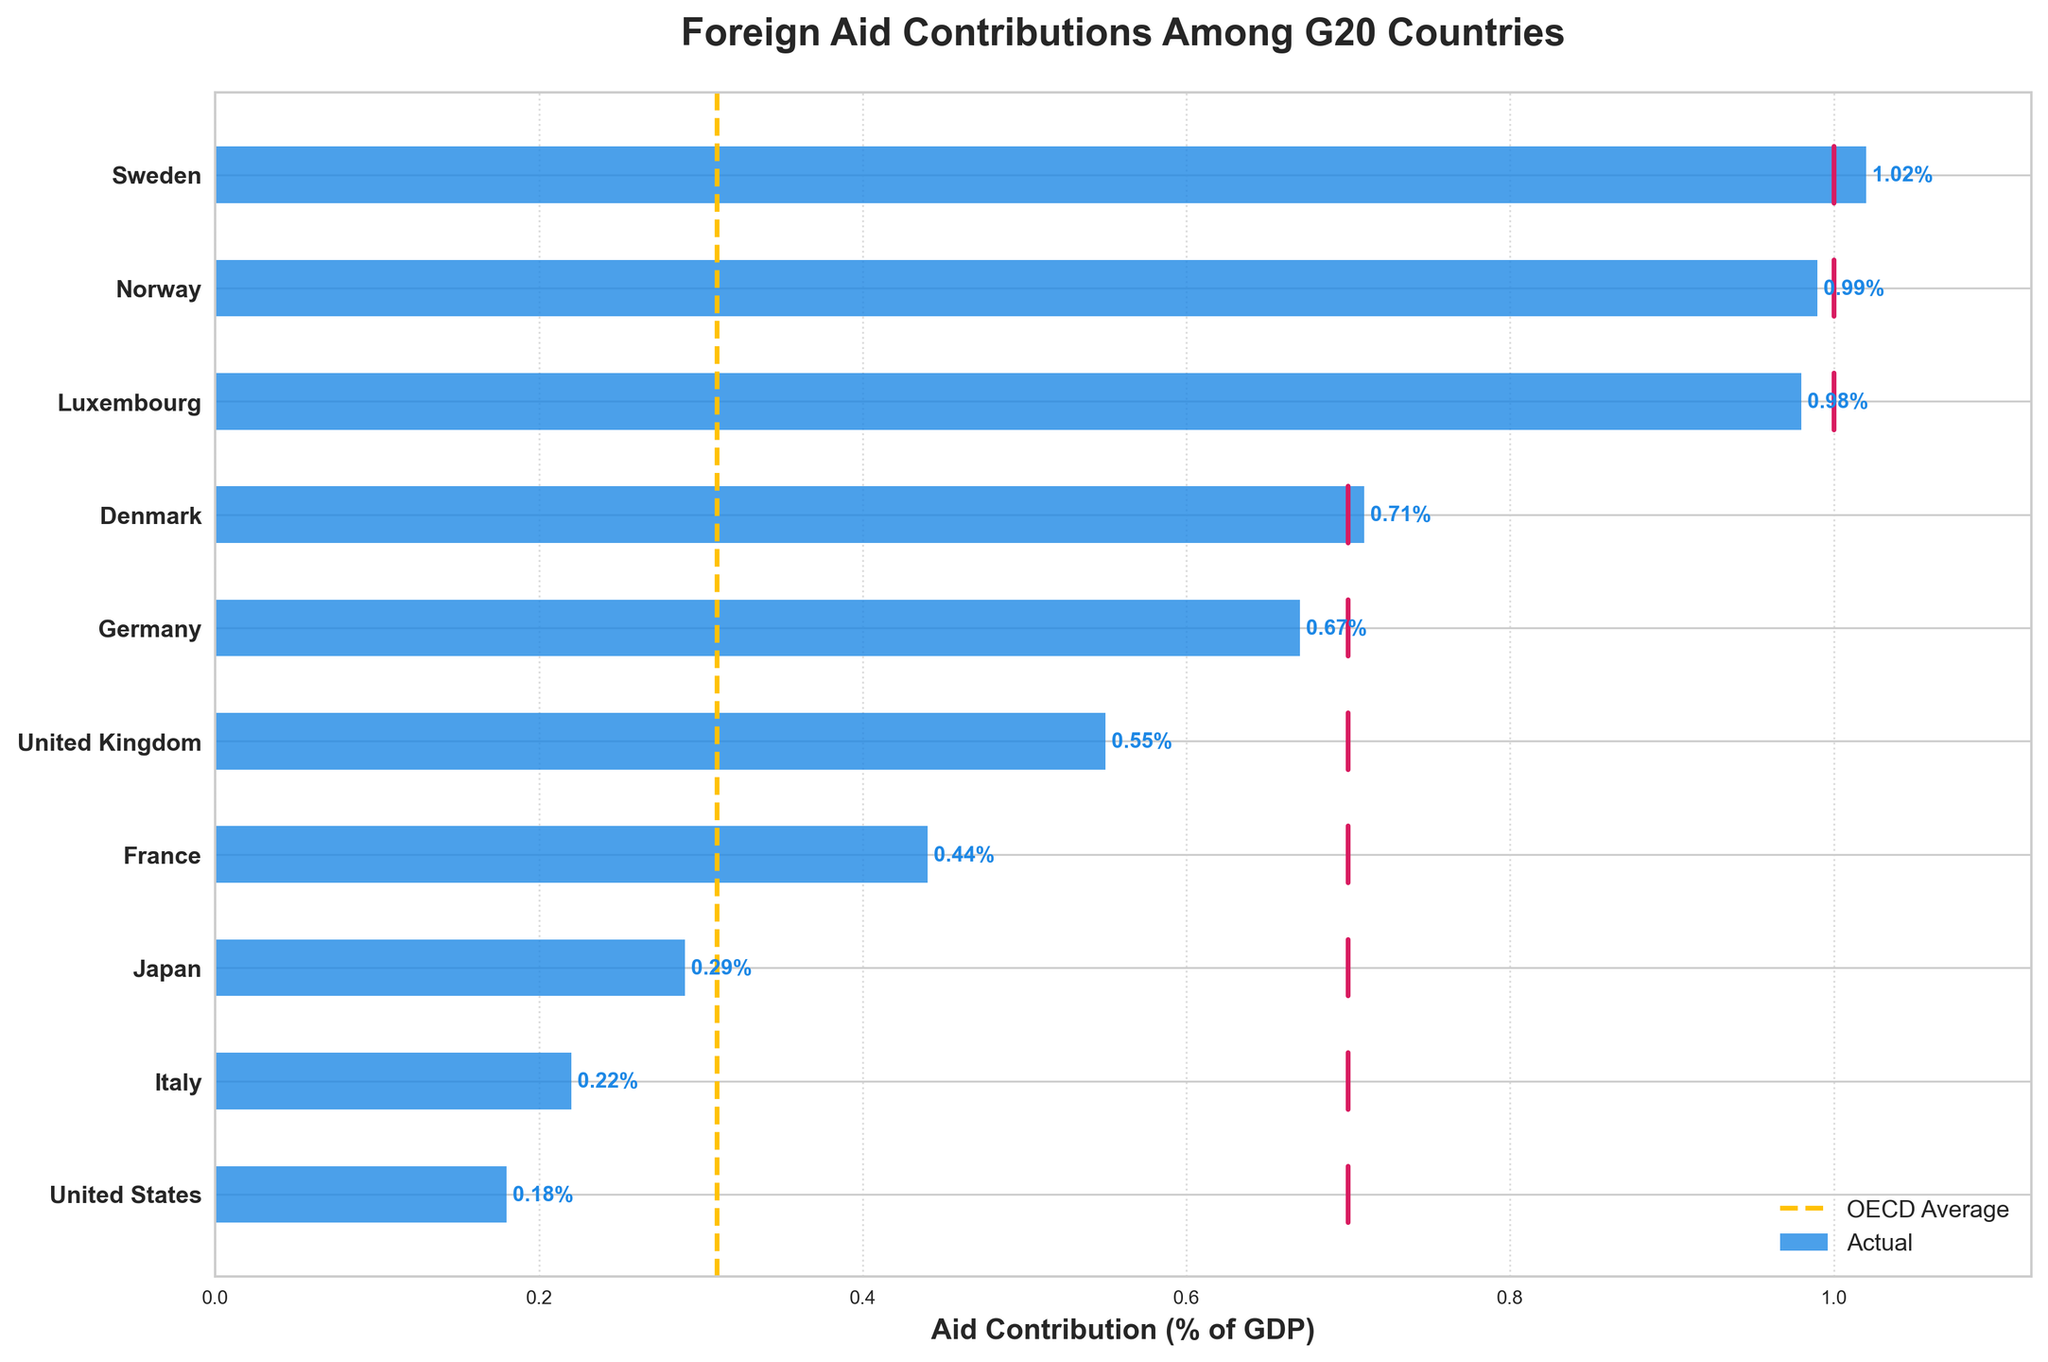What is the title of the figure? The title of the figure is prominently displayed at the top. It reads "Foreign Aid Contributions Among G20 Countries".
Answer: Foreign Aid Contributions Among G20 Countries Which country has the highest actual aid contribution as a percentage of GDP? The highest actual aid contribution as a percentage of GDP is represented by the longest blue bar in the figure. The country associated with this bar is Sweden.
Answer: Sweden How does the United States' actual aid contribution compare to its target aid contribution? The United States' actual aid contribution is shown by the length of its blue bar. The target aid contribution is indicated by a vertical line for each country. For the United States, its actual contribution is 0.18% of GDP, while the target is 0.70%. Thus, the United States' actual contribution is significantly lower than its target contribution.
Answer: Significantly lower What is the range of actual aid contributions among the listed countries? To find the range, identify the highest and lowest actual aid contributions. Sweden has the highest actual aid contribution (1.02%) and the United States has the lowest (0.18%). Subtract the lowest value from the highest value: 1.02% - 0.18% = 0.84%.
Answer: 0.84% Which countries have actual aid contributions that are higher than the OECD average? The OECD average is indicated by a dashed vertical line at 0.31%. The countries whose blue bars extend beyond this line are Sweden, Norway, Luxembourg, Denmark, Germany, and the United Kingdom.
Answer: Sweden, Norway, Luxembourg, Denmark, Germany, United Kingdom Are there any countries where the actual aid contribution is equal to or exceeds the target aid contribution? Compare the lengths of the blue bars (actual contributions) to their respective red lines (target contributions). Sweden, Norway, and Luxembourg have actual contributions that are equal to or slightly below their target contributions, but none exceed their targets. Denmark is the only country where the actual contribution equals the target contribution (0.71%).
Answer: Denmark What is the average target aid contribution among the listed countries? To find the average target aid contribution, add up all the target values and divide by the number of countries. The sum of the targets is 1.00 + 1.00 + 1.00 + 0.70 + 0.70 + 0.70 + 0.70 + 0.70 + 0.70 + 0.70 = 8.90. There are 10 countries, so the average target aid contribution is 8.90 / 10 = 0.89%.
Answer: 0.89% Which country has the smallest difference between its actual aid contribution and its target aid contribution? Calculate the difference between actual and target aid contributions for each country. The smallest difference is found for Denmark (target: 0.71%, actual: 0.71%, difference: 0.00%).
Answer: Denmark How many countries have target aid contributions set at 0.70% of GDP? Count the number of times the value 0.70 appears in the target aid contributions column. Seven countries (Denmark, Germany, United Kingdom, France, Japan, Italy, and United States) have a target aid contribution of 0.70%.
Answer: 7 